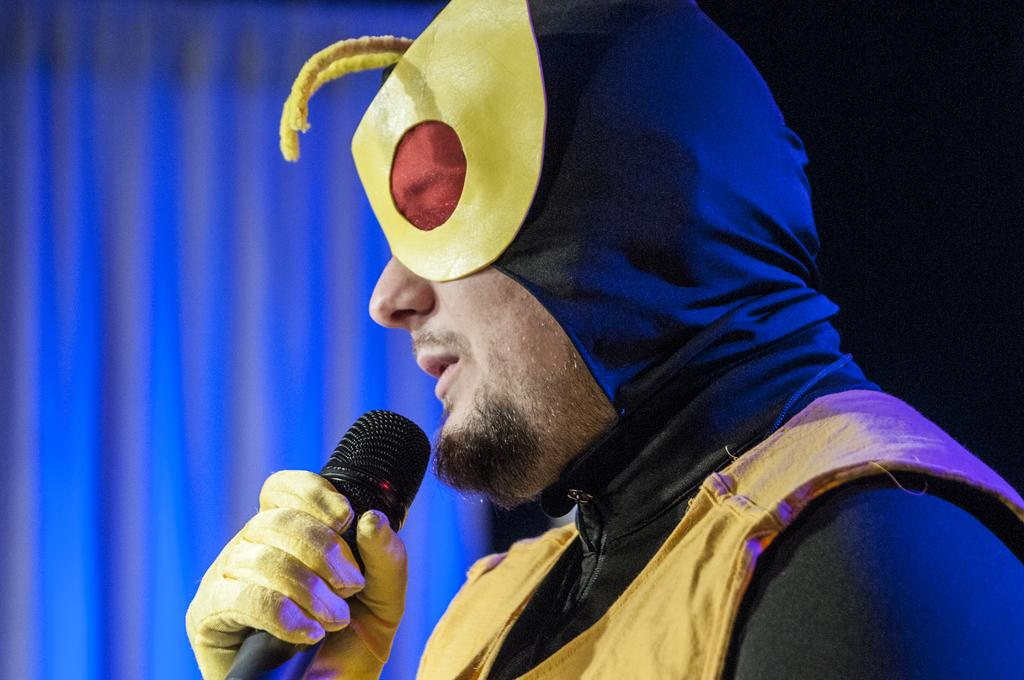What is the gender of the person on the right side of the image? The person on the right side of the image is a man. What is the man wearing in the image? The man is wearing a fancy dress in the image. What object is the man holding in his hand? The man is holding a microphone in his hand. Can you describe the background of the image? There is a cloth visible in the background of the image. How many ants can be seen crawling on the man's dress in the image? There are no ants visible on the man's dress in the image. Can you describe the romantic interaction between the man and the woman in the image? There is no woman present in the image, and no romantic interaction can be observed. 